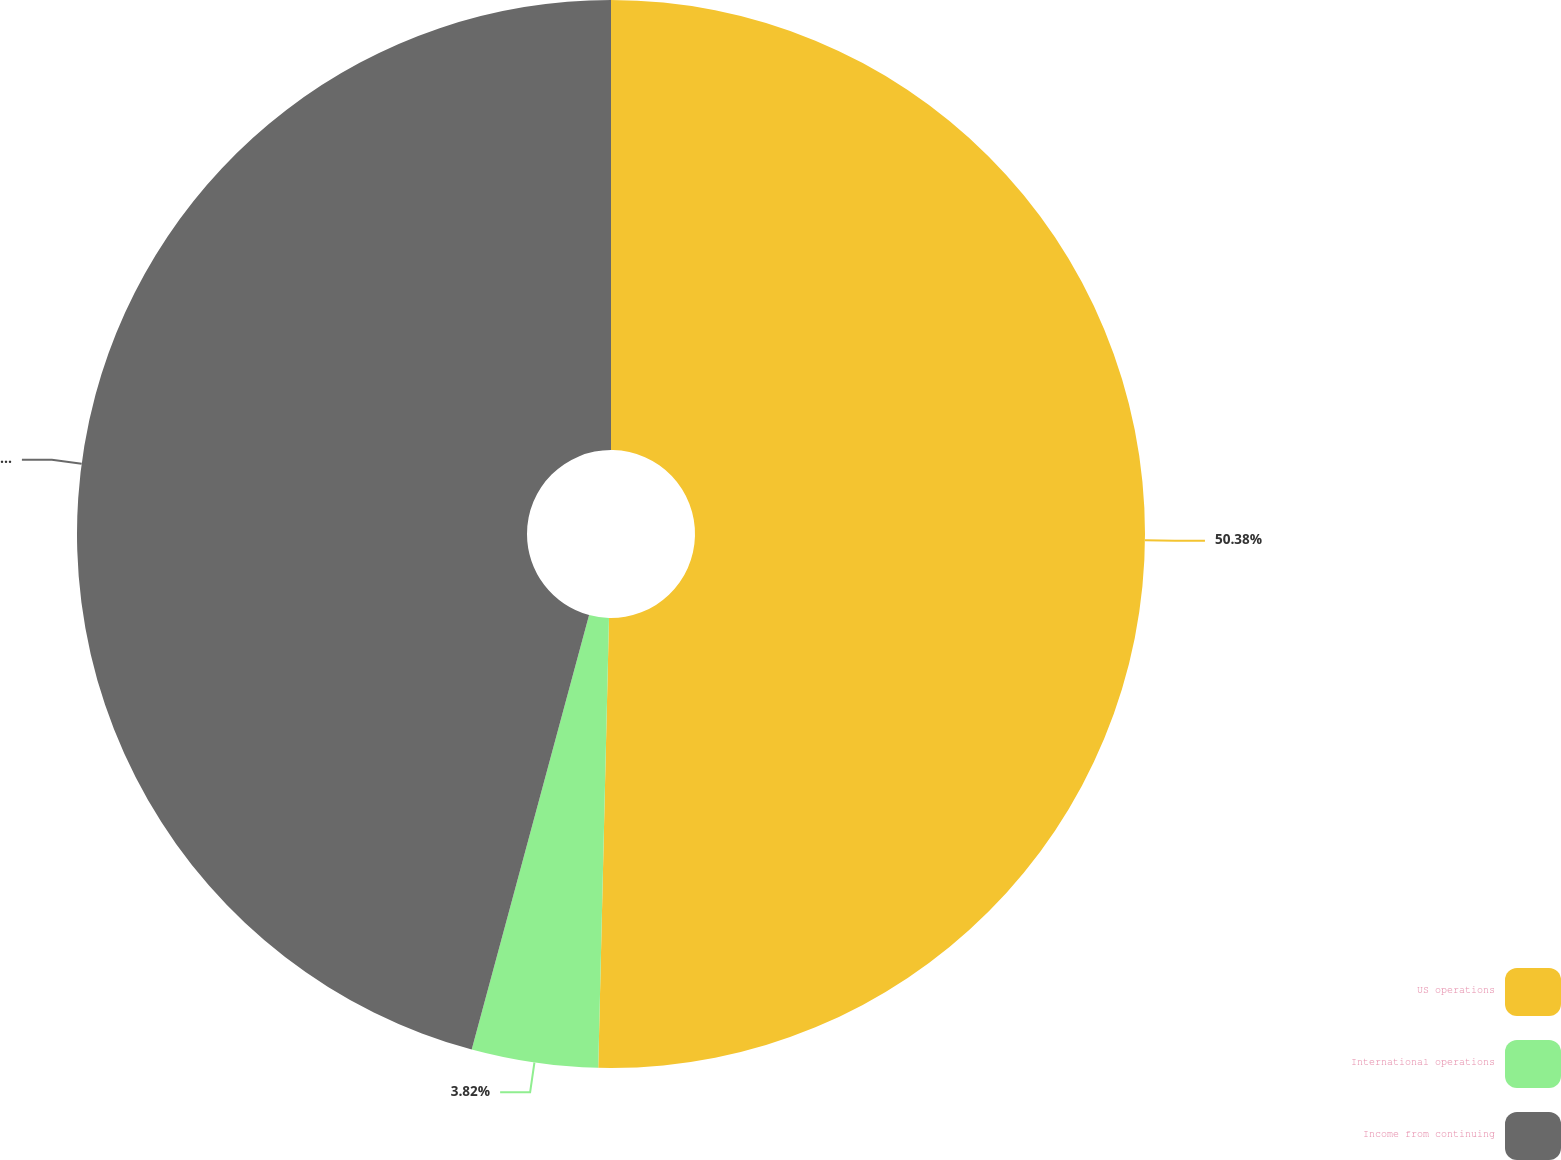Convert chart. <chart><loc_0><loc_0><loc_500><loc_500><pie_chart><fcel>US operations<fcel>International operations<fcel>Income from continuing<nl><fcel>50.38%<fcel>3.82%<fcel>45.8%<nl></chart> 